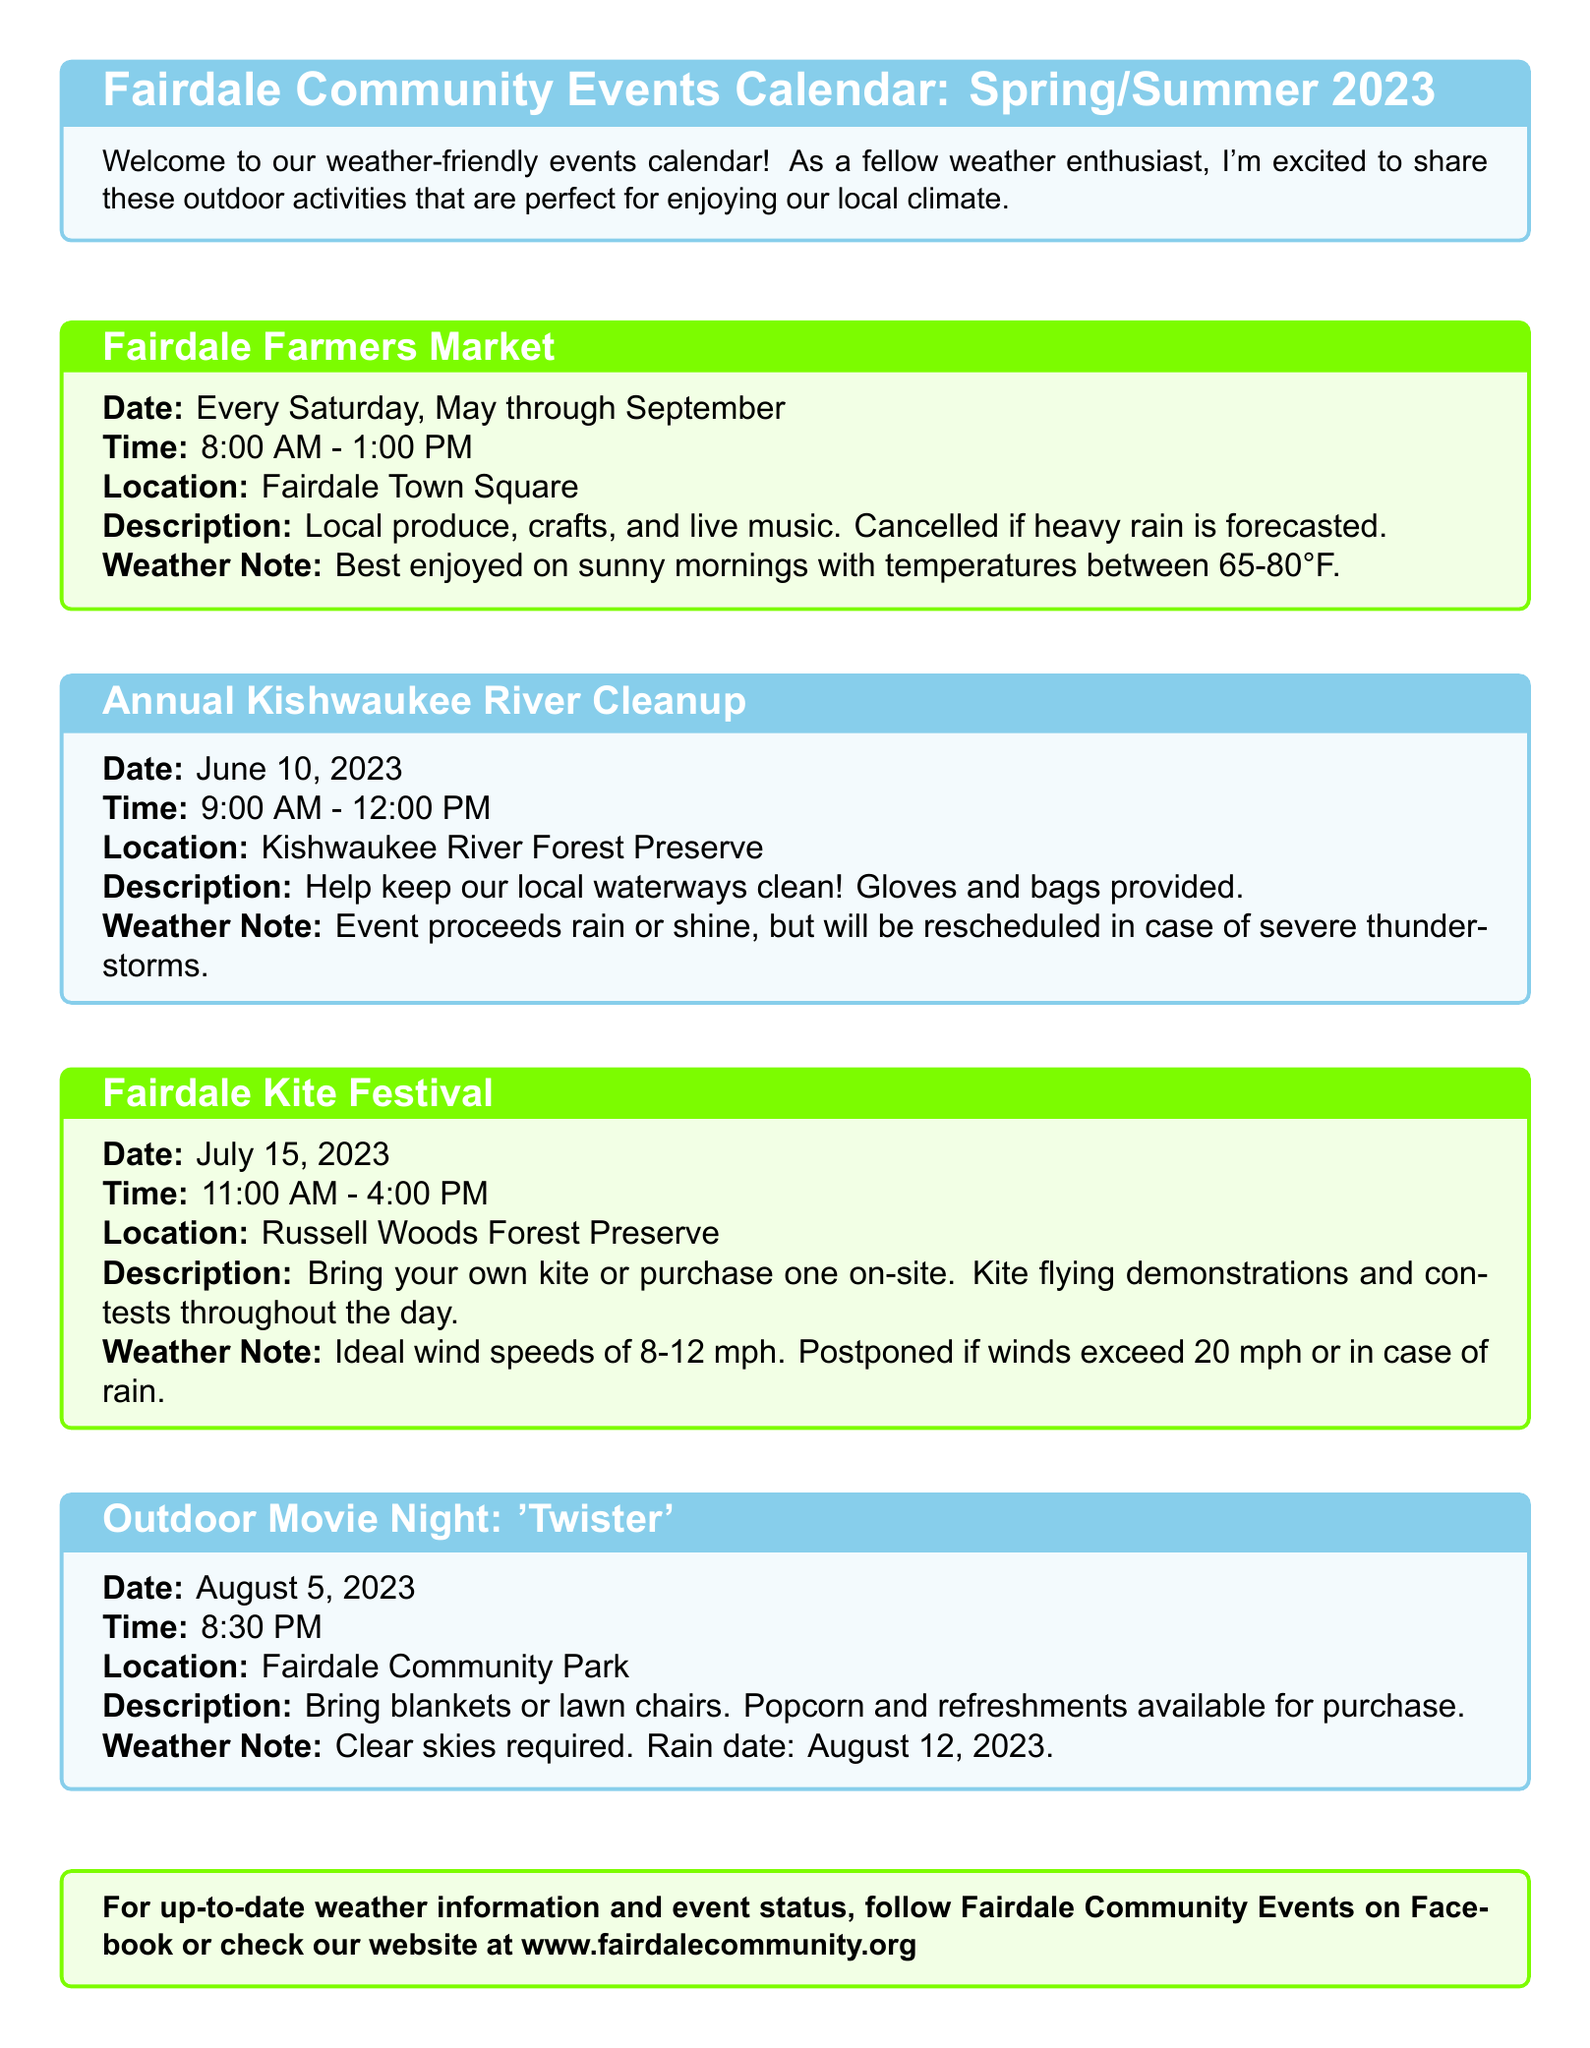What is the location of the Fairdale Farmers Market? The Fairdale Farmers Market takes place at Fairdale Town Square as mentioned in the document.
Answer: Fairdale Town Square On what date is the Annual Kishwaukee River Cleanup scheduled? The Annual Kishwaukee River Cleanup is specifically scheduled for June 10, 2023, as indicated in the document.
Answer: June 10, 2023 What time does the Fairdale Kite Festival start? The document states that the Fairdale Kite Festival begins at 11:00 AM.
Answer: 11:00 AM What type of weather is required for the Outdoor Movie Night? According to the document, clear skies are required for the Outdoor Movie Night to proceed.
Answer: Clear skies What will happen if it rains during the Fairdale Farmers Market? The document notes that the Fairdale Farmers Market will be cancelled if heavy rain is forecasted.
Answer: Cancelled What is the ideal wind speed for the Fairdale Kite Festival? The ideal wind speeds for the Fairdale Kite Festival, as per the document, are 8-12 mph.
Answer: 8-12 mph What is the rain date for the Outdoor Movie Night? The rain date for the Outdoor Movie Night is explicitly mentioned as August 12, 2023.
Answer: August 12, 2023 How can one stay updated on weather information and event status? The document advises following Fairdale Community Events on Facebook or checking their website for updates.
Answer: Fairdale Community Events on Facebook or website 